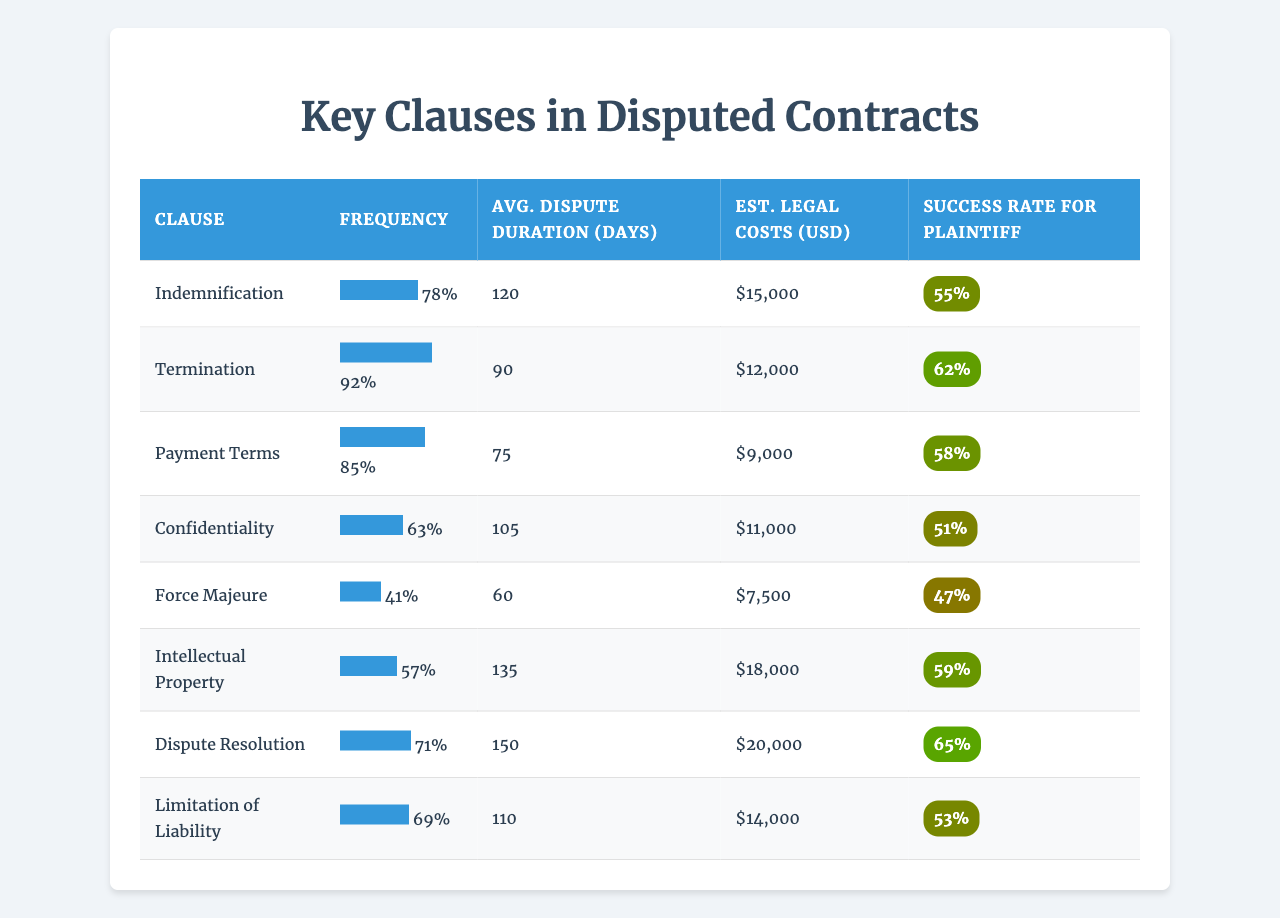What clause has the highest frequency in disputed contracts? The frequency data shows that the clause "Termination" has the highest frequency at 92%.
Answer: Termination What is the average dispute duration for the clause "Intellectual Property"? The table indicates that the average dispute duration for "Intellectual Property" is 135 days.
Answer: 135 days What is the estimated legal cost for disputes involving "Confidentiality"? Looking at the legal costs column, the estimated legal cost for "Confidentiality" is $11,000.
Answer: $11,000 Which clause has the lowest success rate for the plaintiff? By examining the success rates, "Force Majeure" has the lowest success rate at 47%.
Answer: Force Majeure How much higher is the average dispute duration for "Dispute Resolution" compared to "Payment Terms"? The average duration for "Dispute Resolution" is 150 days and for "Payment Terms" is 75 days. The difference is 150 - 75 = 75 days.
Answer: 75 days Is it true that the estimated legal cost for "Limitation of Liability" is higher than for "Payment Terms"? The estimated legal cost for "Limitation of Liability" is $14,000 and for "Payment Terms" is $9,000, making the statement true.
Answer: True What is the average success rate for clauses with a frequency of over 75%? The clauses with a frequency over 75% are "Termination," "Payment Terms," "Indemnification," and "Dispute Resolution." Their success rates are 62%, 58%, 55%, and 65% respectively. The average is (62 + 58 + 55 + 65)/4 = 60%.
Answer: 60% Which clause typically involves the highest estimated legal costs? The clause with the highest estimated legal cost is "Dispute Resolution" at $20,000.
Answer: Dispute Resolution What is the relationship between frequency and success rate for "Payment Terms"? The frequency for "Payment Terms" is 85% with a success rate of 58%. This shows a moderate success rate relative to its high frequency, indicating it is commonly disputed but not always favorably resolved for the plaintiff.
Answer: Moderate relationship Which clause has the highest average cost and the lowest success rate for the plaintiff? The clause "Dispute Resolution" has the highest average cost at $20,000 and a success rate of 65%, which is not the lowest. The clause "Force Majeure" has the lowest success rate at 47% but has a lower average cost than "Dispute Resolution."
Answer: No clause fits this description 